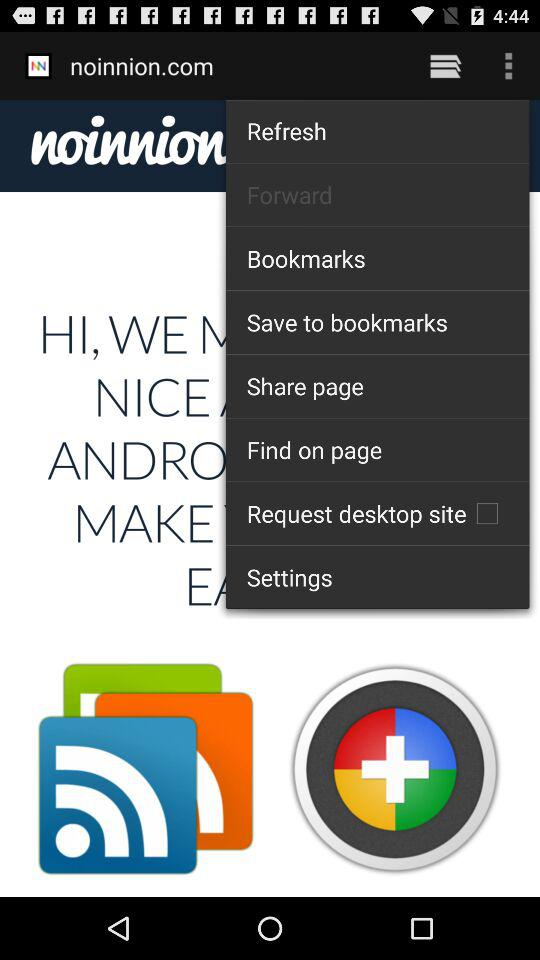What is the status of "Request desktop site"? The status is off. 